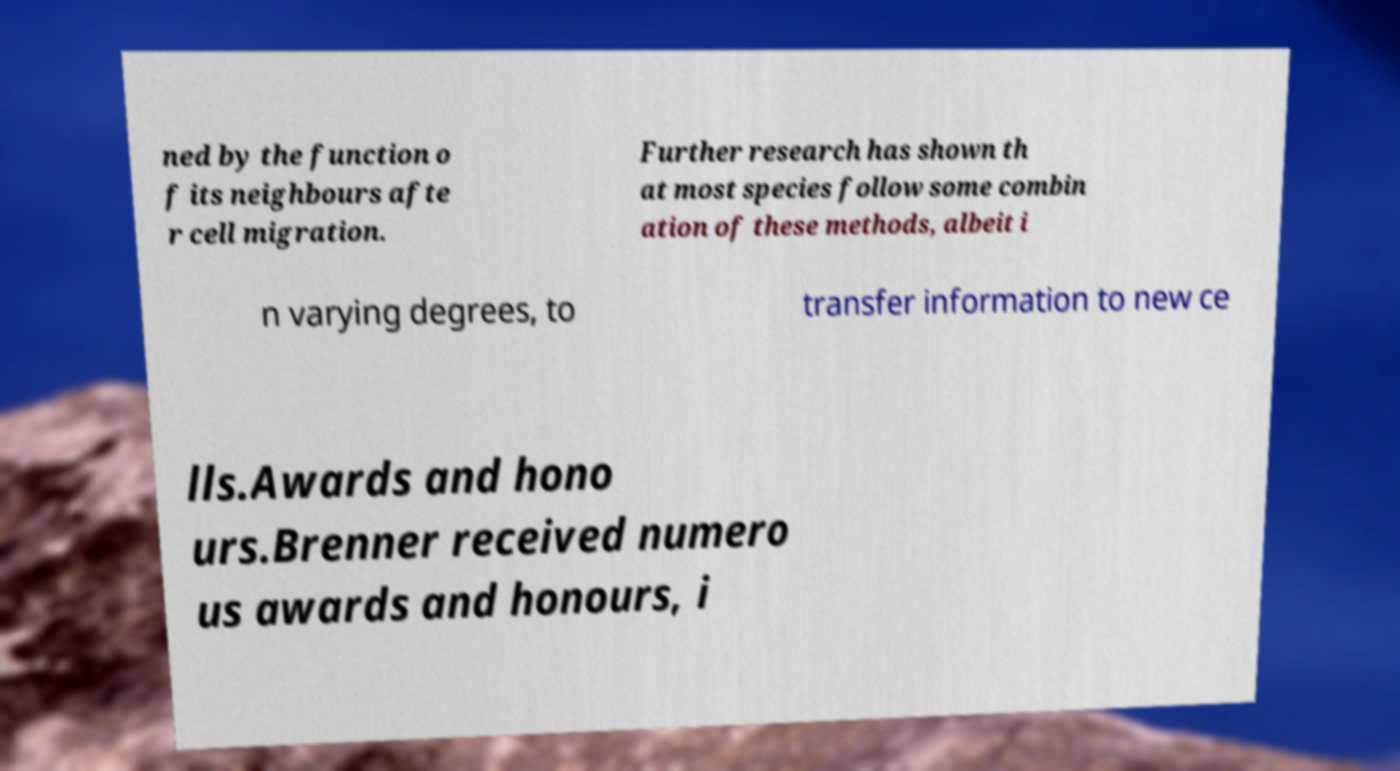Can you accurately transcribe the text from the provided image for me? ned by the function o f its neighbours afte r cell migration. Further research has shown th at most species follow some combin ation of these methods, albeit i n varying degrees, to transfer information to new ce lls.Awards and hono urs.Brenner received numero us awards and honours, i 